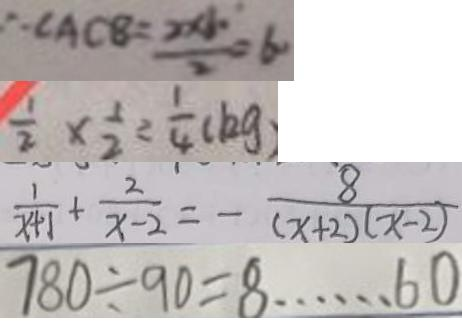Convert formula to latex. <formula><loc_0><loc_0><loc_500><loc_500>\therefore \angle A C B = \frac { 2 \times 1 0 } { 2 } = 6 \cdot 
 \frac { 1 } { 2 } \times \frac { 1 } { 2 } = \frac { 1 } { 4 } ( k g ) 
 \frac { 1 } { x + 1 } + \frac { 2 } { x - 2 } = - \frac { 8 } { ( x + 2 ) ( x - 2 ) } 
 7 8 0 \div 9 0 = 8 \cdots 6 0</formula> 